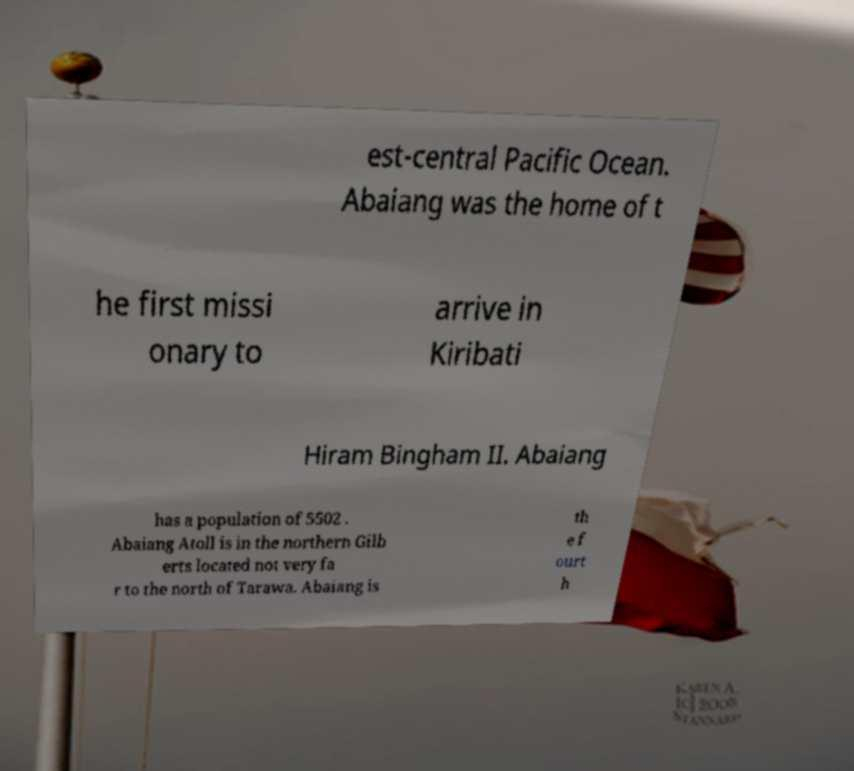What messages or text are displayed in this image? I need them in a readable, typed format. est-central Pacific Ocean. Abaiang was the home of t he first missi onary to arrive in Kiribati Hiram Bingham II. Abaiang has a population of 5502 . Abaiang Atoll is in the northern Gilb erts located not very fa r to the north of Tarawa. Abaiang is th e f ourt h 